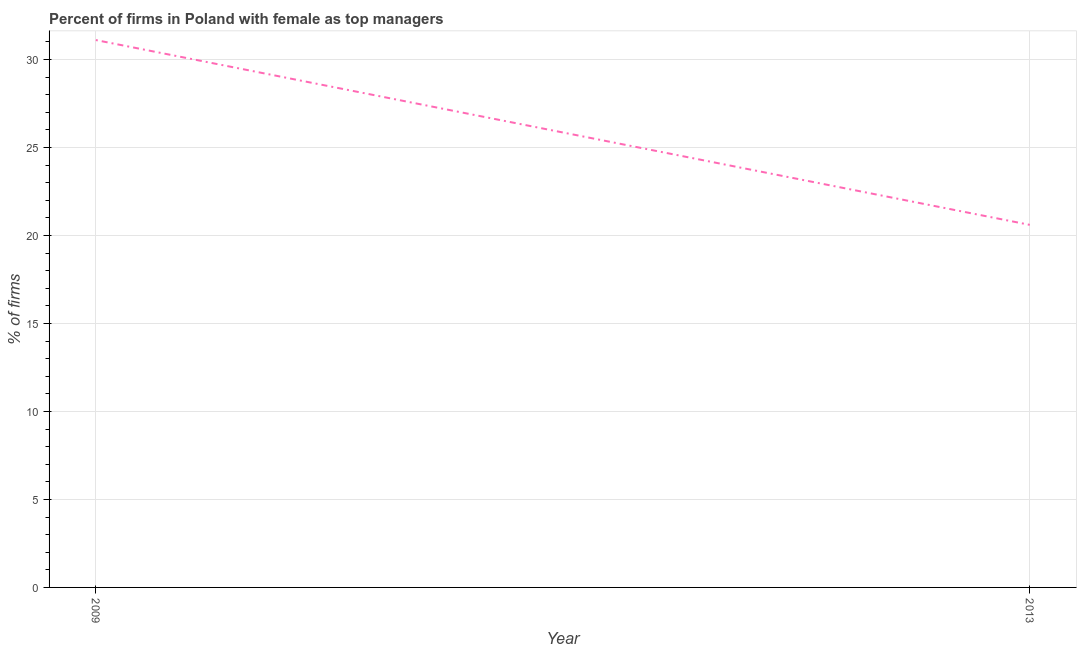What is the percentage of firms with female as top manager in 2013?
Your answer should be compact. 20.6. Across all years, what is the maximum percentage of firms with female as top manager?
Offer a terse response. 31.1. Across all years, what is the minimum percentage of firms with female as top manager?
Offer a very short reply. 20.6. In which year was the percentage of firms with female as top manager maximum?
Make the answer very short. 2009. What is the sum of the percentage of firms with female as top manager?
Keep it short and to the point. 51.7. What is the average percentage of firms with female as top manager per year?
Provide a short and direct response. 25.85. What is the median percentage of firms with female as top manager?
Provide a succinct answer. 25.85. What is the ratio of the percentage of firms with female as top manager in 2009 to that in 2013?
Keep it short and to the point. 1.51. Is the percentage of firms with female as top manager in 2009 less than that in 2013?
Offer a terse response. No. Does the percentage of firms with female as top manager monotonically increase over the years?
Keep it short and to the point. No. How many years are there in the graph?
Provide a short and direct response. 2. What is the difference between two consecutive major ticks on the Y-axis?
Your response must be concise. 5. Are the values on the major ticks of Y-axis written in scientific E-notation?
Give a very brief answer. No. Does the graph contain grids?
Your answer should be compact. Yes. What is the title of the graph?
Your answer should be very brief. Percent of firms in Poland with female as top managers. What is the label or title of the Y-axis?
Ensure brevity in your answer.  % of firms. What is the % of firms in 2009?
Provide a succinct answer. 31.1. What is the % of firms of 2013?
Offer a terse response. 20.6. What is the ratio of the % of firms in 2009 to that in 2013?
Make the answer very short. 1.51. 